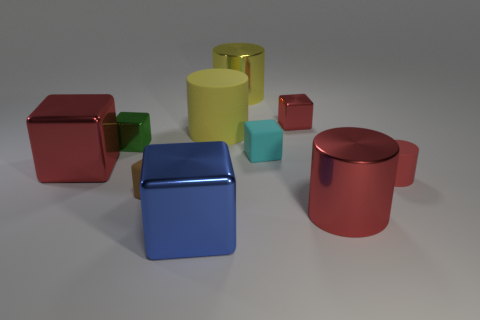What size is the other cylinder that is the same color as the small matte cylinder?
Make the answer very short. Large. What number of big things are either metallic things or brown matte cylinders?
Make the answer very short. 4. Is there anything else of the same color as the big rubber object?
Offer a very short reply. Yes. There is a large block that is behind the metal block that is in front of the large red metallic object in front of the small cylinder; what is its material?
Offer a terse response. Metal. What number of metal objects are either large cyan balls or small cylinders?
Your answer should be compact. 0. How many green objects are either small metal objects or tiny objects?
Make the answer very short. 1. Do the large block behind the big blue object and the big rubber thing have the same color?
Your answer should be compact. No. Is the material of the brown block the same as the tiny green cube?
Offer a terse response. No. Are there an equal number of yellow matte cylinders in front of the brown object and large red cylinders on the right side of the small red cylinder?
Your response must be concise. Yes. There is another yellow object that is the same shape as the yellow metal object; what is its material?
Your answer should be very brief. Rubber. 